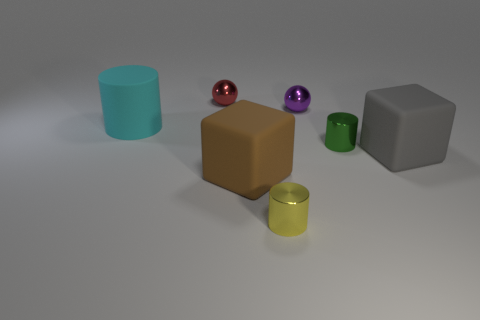Subtract all green blocks. Subtract all brown balls. How many blocks are left? 2 Add 3 tiny green things. How many objects exist? 10 Subtract all blocks. How many objects are left? 5 Subtract 0 cyan cubes. How many objects are left? 7 Subtract all tiny purple metallic objects. Subtract all brown rubber things. How many objects are left? 5 Add 2 tiny yellow shiny objects. How many tiny yellow shiny objects are left? 3 Add 4 large red matte spheres. How many large red matte spheres exist? 4 